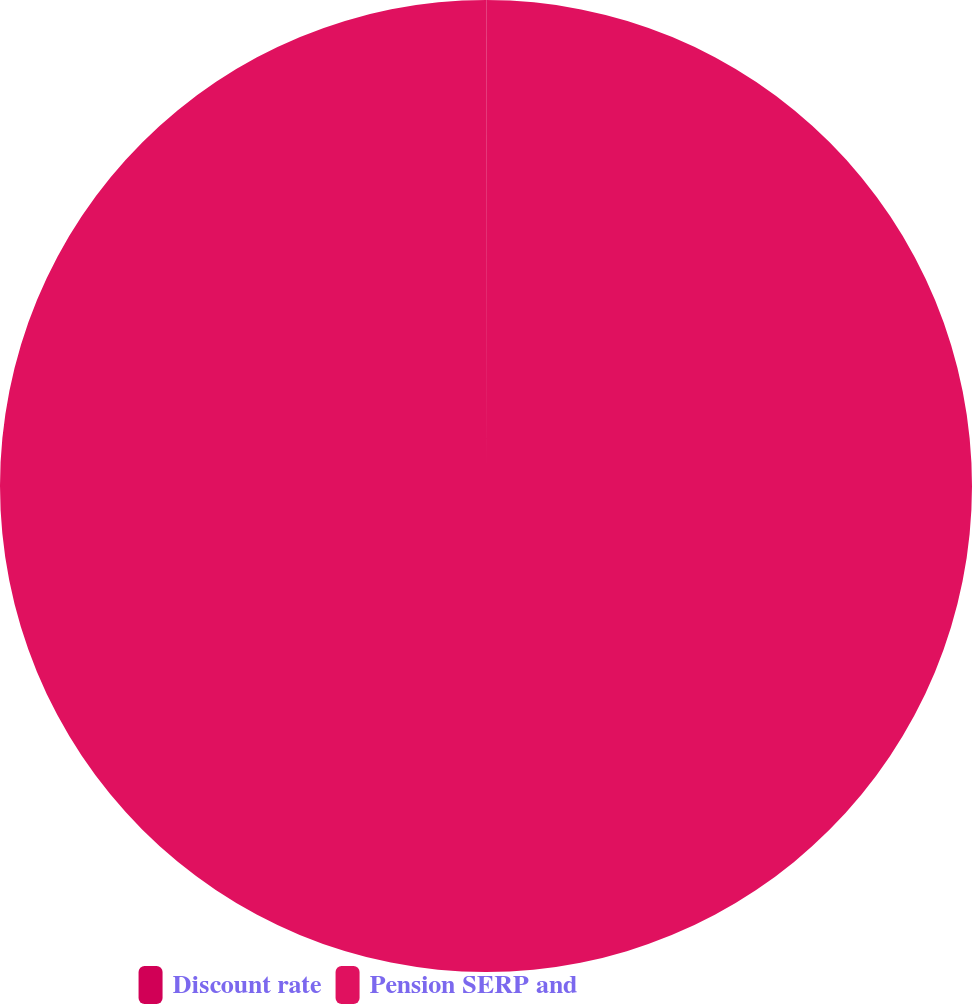Convert chart. <chart><loc_0><loc_0><loc_500><loc_500><pie_chart><fcel>Discount rate<fcel>Pension SERP and<nl><fcel>0.01%<fcel>99.99%<nl></chart> 